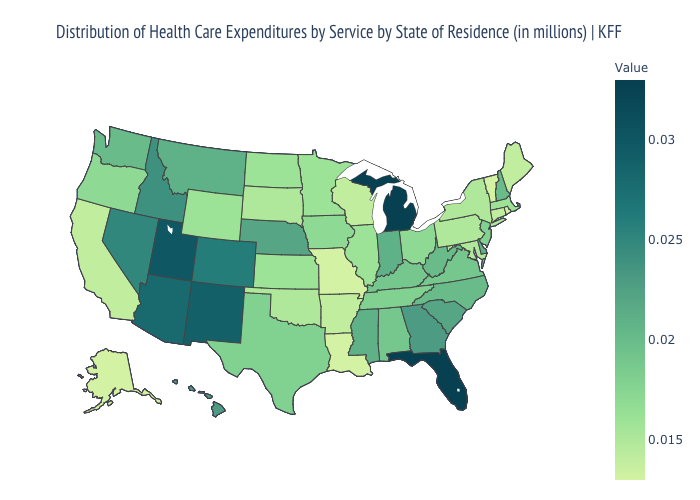Does Florida have the highest value in the South?
Be succinct. Yes. Among the states that border Kansas , does Missouri have the highest value?
Answer briefly. No. Which states hav the highest value in the West?
Keep it brief. Utah. Among the states that border Delaware , does Pennsylvania have the highest value?
Give a very brief answer. No. Does West Virginia have a higher value than Oregon?
Concise answer only. Yes. 